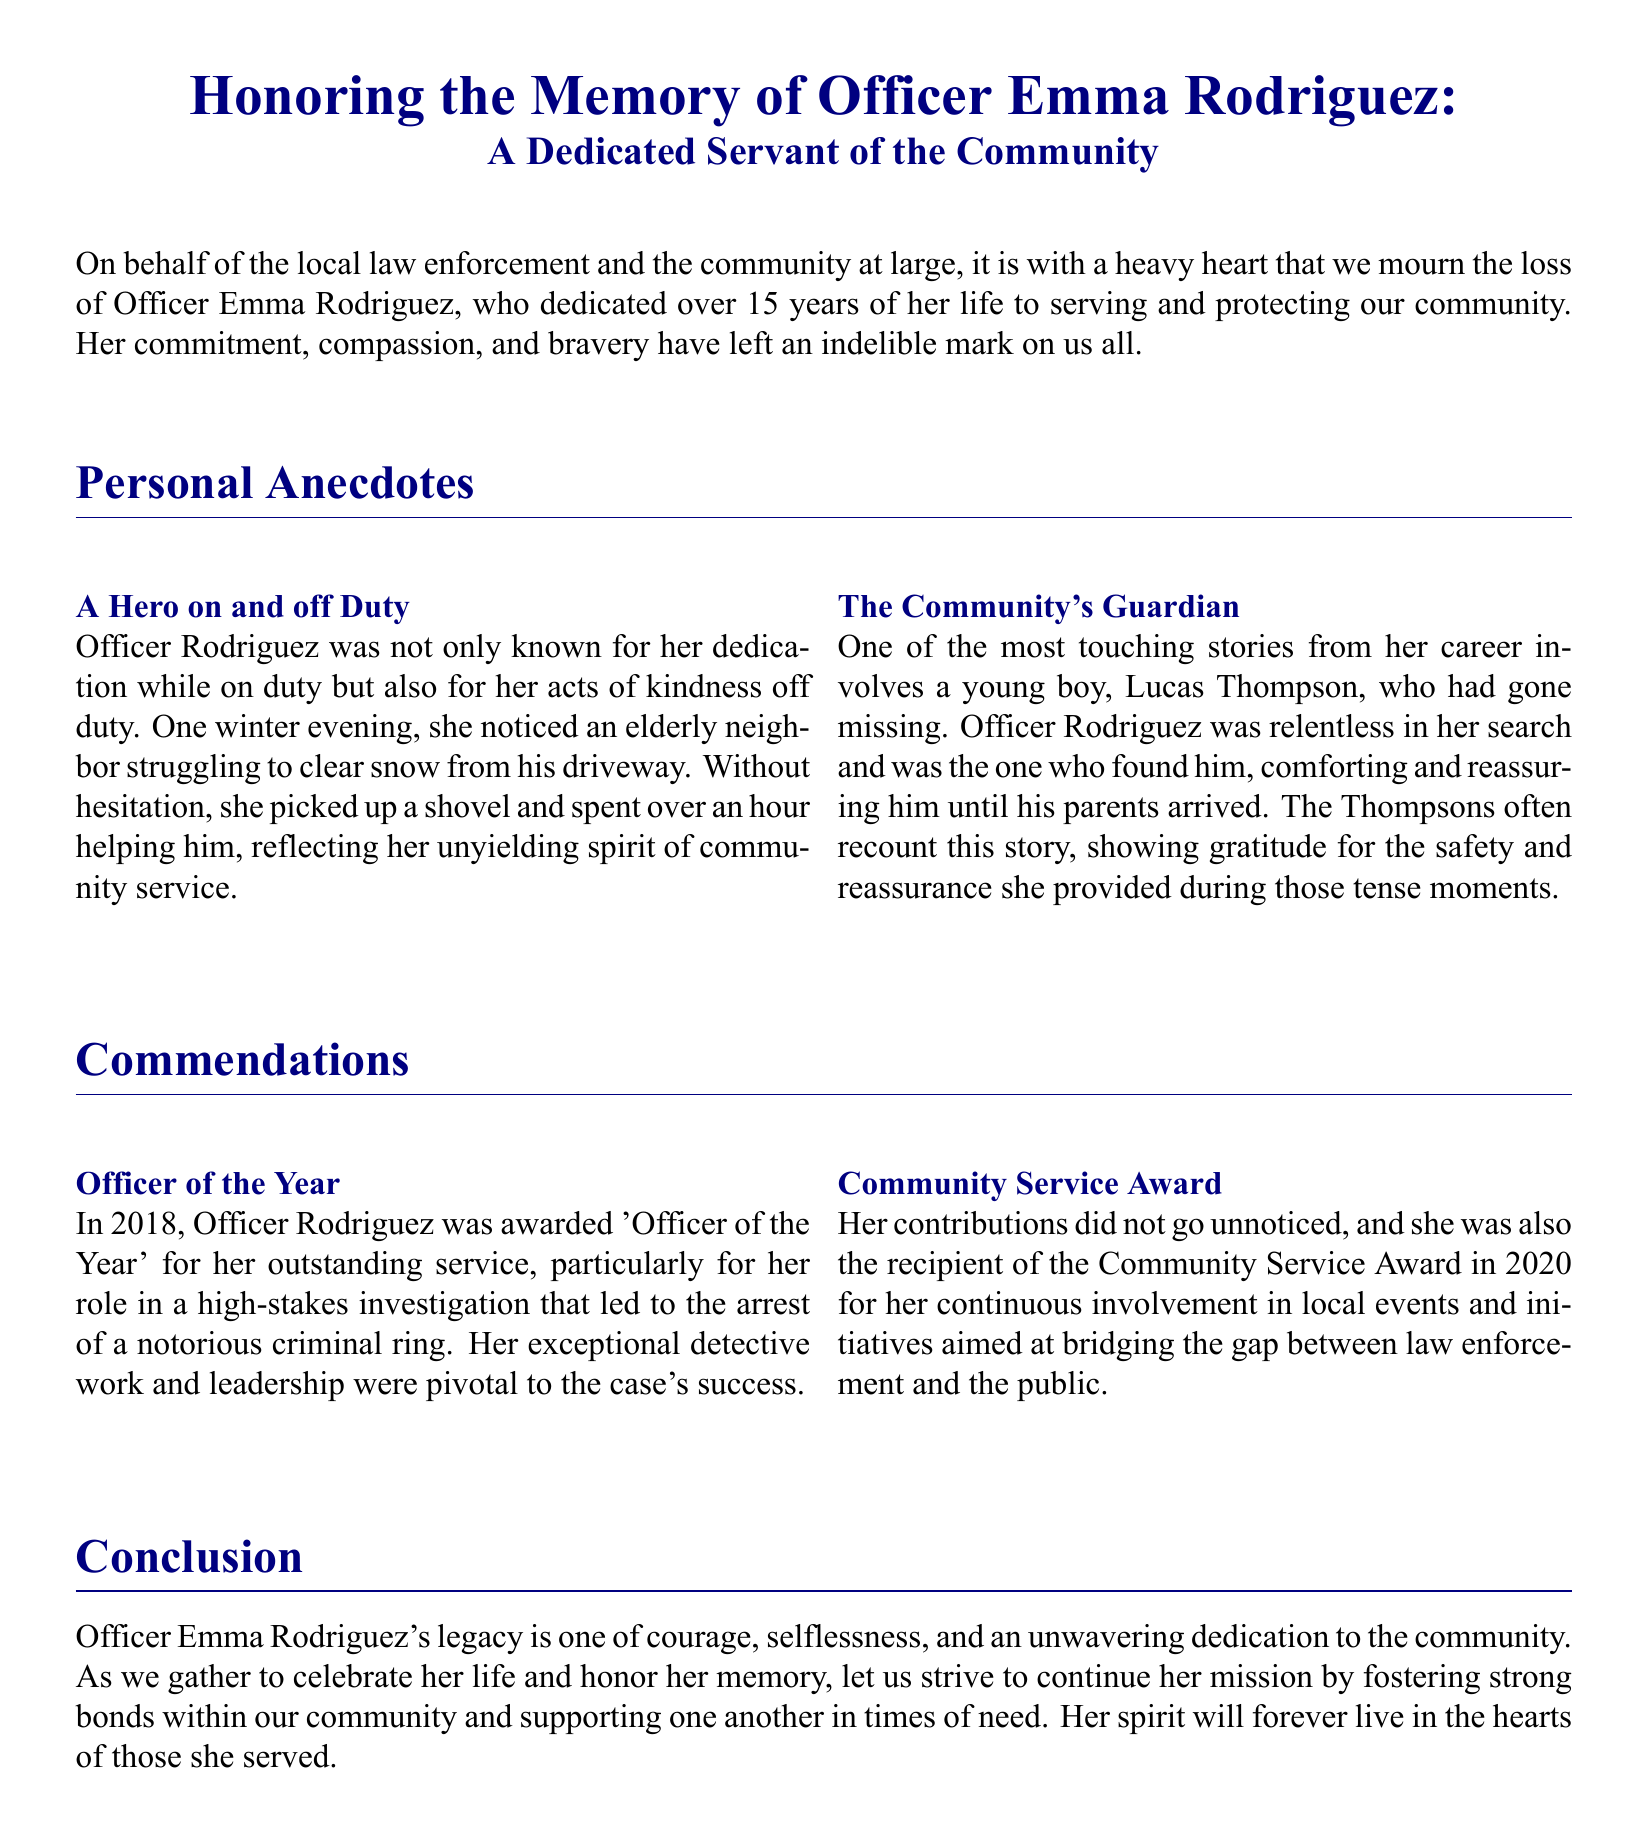What is the name of the officer being honored? The document specifically states the name of the officer being honored as Officer Emma Rodriguez.
Answer: Officer Emma Rodriguez How many years did Officer Rodriguez serve? The document mentions that she dedicated over 15 years of her life to serving the community.
Answer: over 15 years In which year did Officer Rodriguez receive the 'Officer of the Year' award? The document states that she was awarded 'Officer of the Year' in 2018 for her outstanding service.
Answer: 2018 What was the notable act of kindness Officer Rodriguez did for her neighbor? The document recounts that she helped an elderly neighbor clear snow from his driveway.
Answer: helped an elderly neighbor clear snow Who is Lucas Thompson in relation to Officer Rodriguez? The document describes Lucas Thompson as a young boy who went missing and was found by Officer Rodriguez.
Answer: a young boy who went missing What award did Officer Rodriguez receive in 2020? The document indicates that she received the Community Service Award in 2020.
Answer: Community Service Award What qualities are highlighted in Officer Rodriguez's legacy? The document emphasizes that her legacy is one of courage, selflessness, and unwavering dedication to the community.
Answer: courage, selflessness, unwavering dedication What type of work was Officer Rodriguez involved in during one of her notable commendations? The document points out that she played a pivotal role in a high-stakes investigation leading to the arrest of a criminal ring.
Answer: high-stakes investigation Which community-focused initiative was highlighted in the commendations? The document notes her involvement in local events and initiatives aimed at bridging the gap between law enforcement and the public.
Answer: bridging the gap between law enforcement and the public 